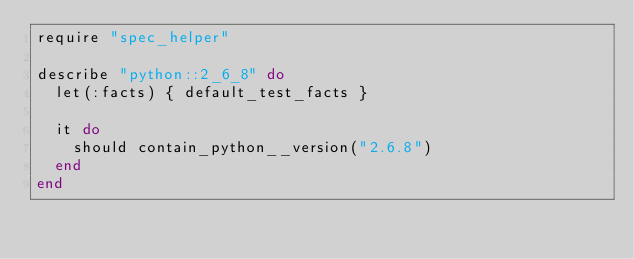<code> <loc_0><loc_0><loc_500><loc_500><_Ruby_>require "spec_helper"

describe "python::2_6_8" do
  let(:facts) { default_test_facts }

  it do
    should contain_python__version("2.6.8")
  end
end
</code> 